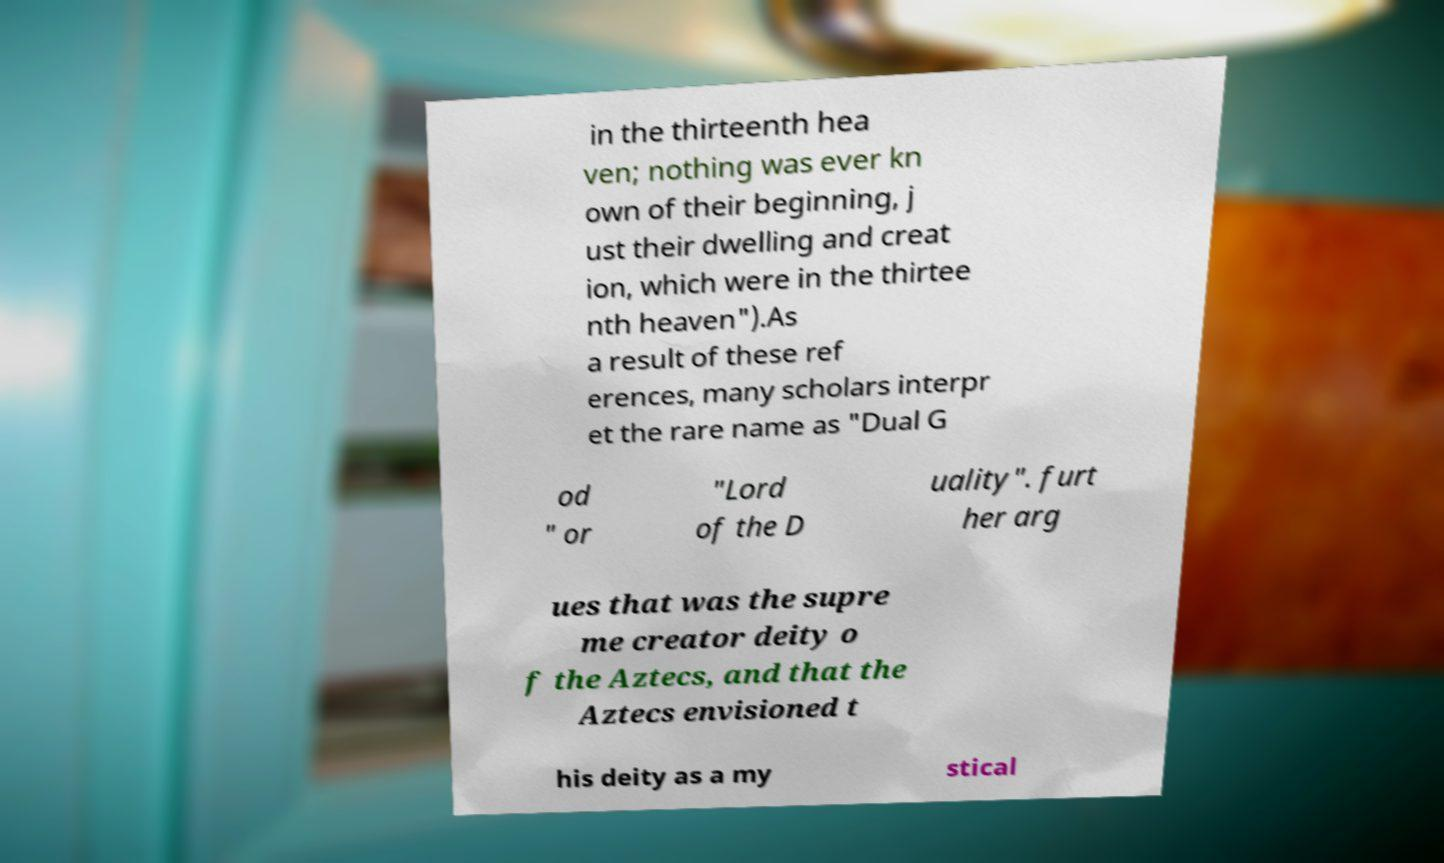Please read and relay the text visible in this image. What does it say? in the thirteenth hea ven; nothing was ever kn own of their beginning, j ust their dwelling and creat ion, which were in the thirtee nth heaven").As a result of these ref erences, many scholars interpr et the rare name as "Dual G od " or "Lord of the D uality". furt her arg ues that was the supre me creator deity o f the Aztecs, and that the Aztecs envisioned t his deity as a my stical 